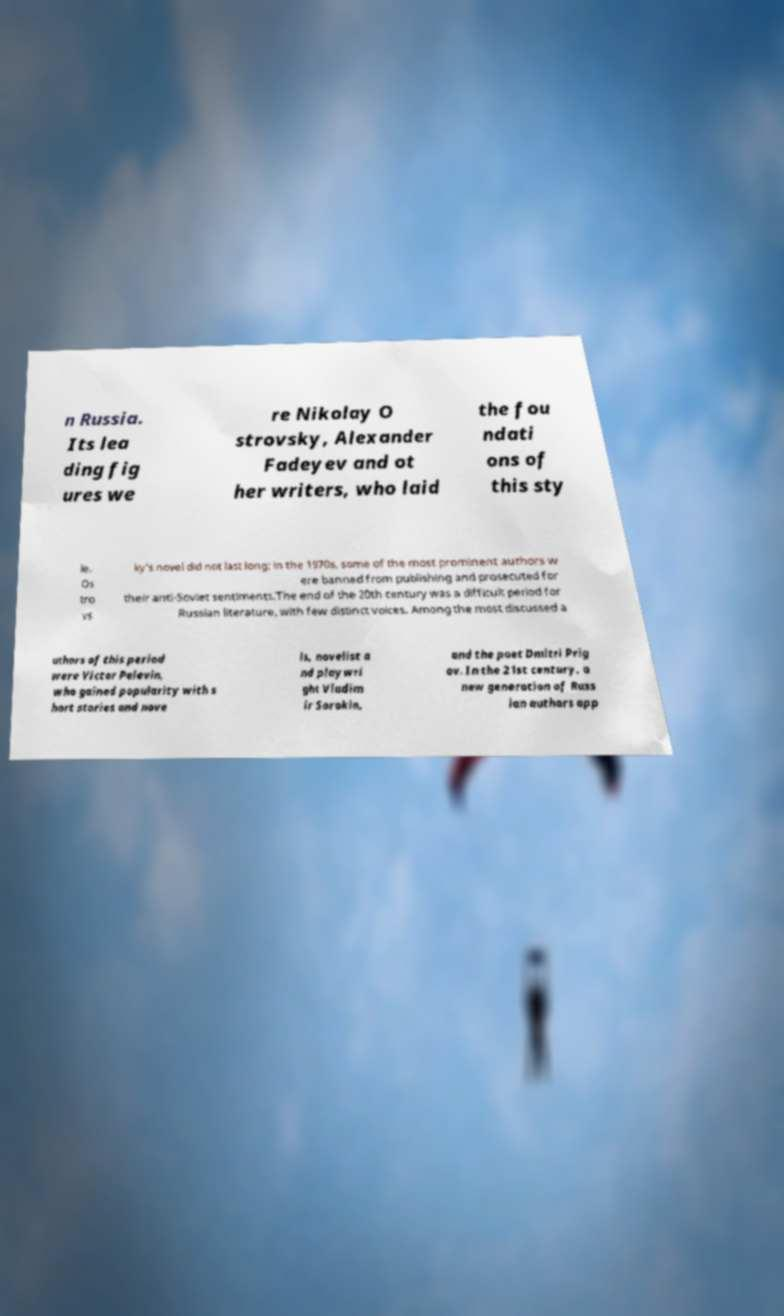Please read and relay the text visible in this image. What does it say? n Russia. Its lea ding fig ures we re Nikolay O strovsky, Alexander Fadeyev and ot her writers, who laid the fou ndati ons of this sty le. Os tro vs ky's novel did not last long; in the 1970s, some of the most prominent authors w ere banned from publishing and prosecuted for their anti-Soviet sentiments.The end of the 20th century was a difficult period for Russian literature, with few distinct voices. Among the most discussed a uthors of this period were Victor Pelevin, who gained popularity with s hort stories and nove ls, novelist a nd playwri ght Vladim ir Sorokin, and the poet Dmitri Prig ov. In the 21st century, a new generation of Russ ian authors app 